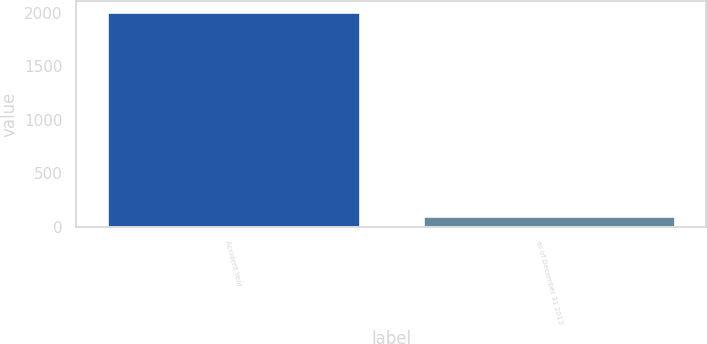Convert chart to OTSL. <chart><loc_0><loc_0><loc_500><loc_500><bar_chart><fcel>Accident Year<fcel>as of December 31 2013<nl><fcel>2012<fcel>100.4<nl></chart> 